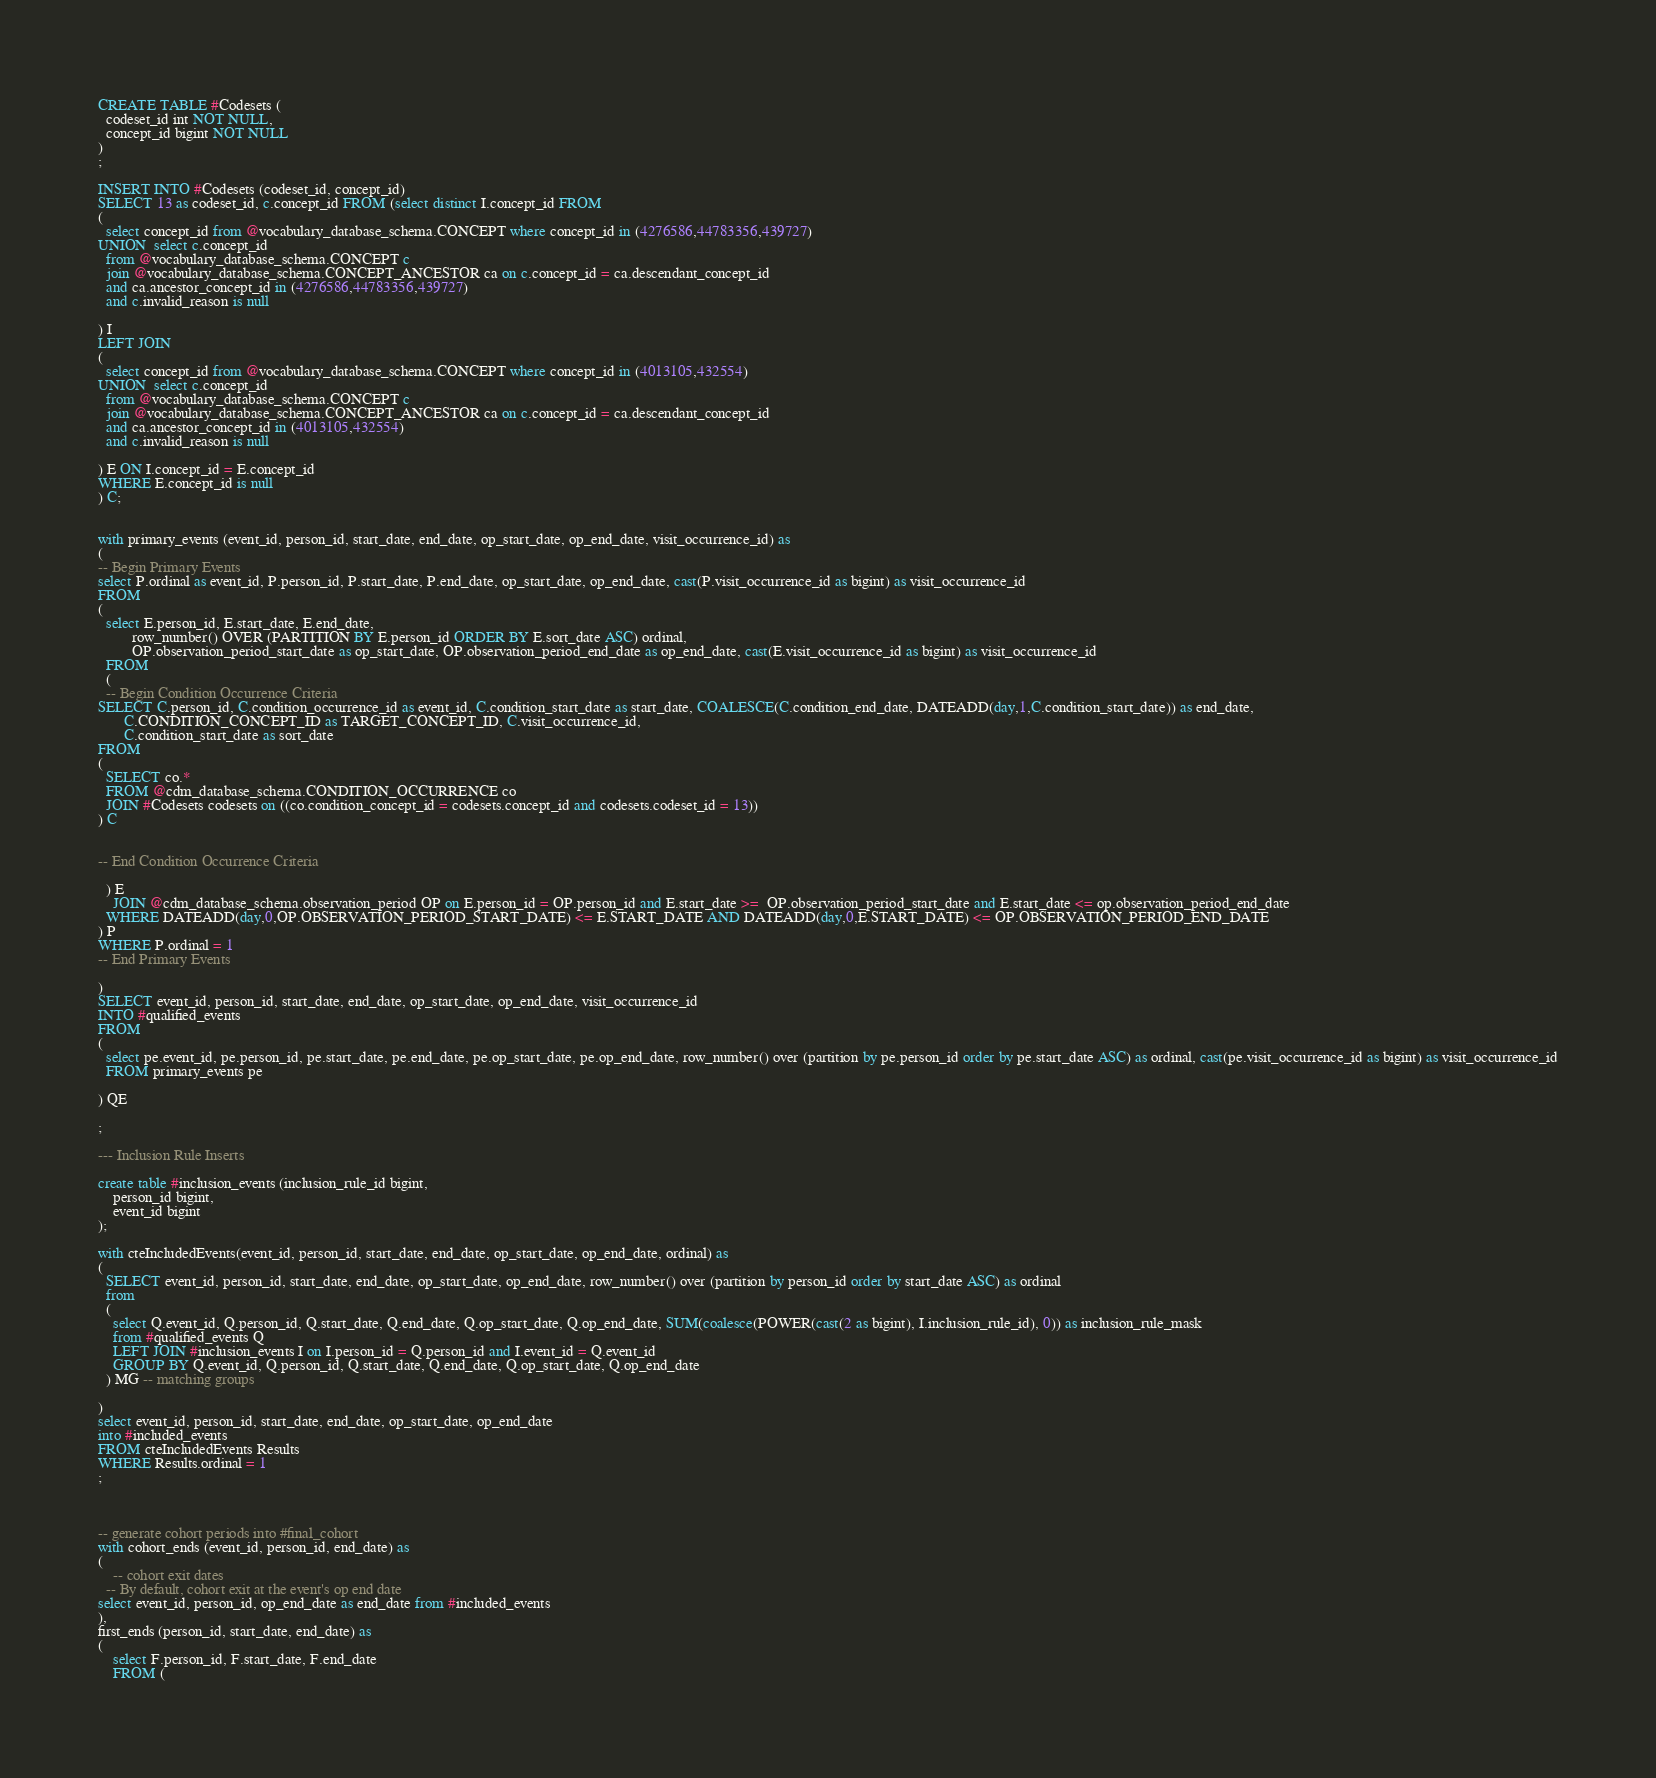Convert code to text. <code><loc_0><loc_0><loc_500><loc_500><_SQL_>CREATE TABLE #Codesets (
  codeset_id int NOT NULL,
  concept_id bigint NOT NULL
)
;

INSERT INTO #Codesets (codeset_id, concept_id)
SELECT 13 as codeset_id, c.concept_id FROM (select distinct I.concept_id FROM
( 
  select concept_id from @vocabulary_database_schema.CONCEPT where concept_id in (4276586,44783356,439727)
UNION  select c.concept_id
  from @vocabulary_database_schema.CONCEPT c
  join @vocabulary_database_schema.CONCEPT_ANCESTOR ca on c.concept_id = ca.descendant_concept_id
  and ca.ancestor_concept_id in (4276586,44783356,439727)
  and c.invalid_reason is null

) I
LEFT JOIN
(
  select concept_id from @vocabulary_database_schema.CONCEPT where concept_id in (4013105,432554)
UNION  select c.concept_id
  from @vocabulary_database_schema.CONCEPT c
  join @vocabulary_database_schema.CONCEPT_ANCESTOR ca on c.concept_id = ca.descendant_concept_id
  and ca.ancestor_concept_id in (4013105,432554)
  and c.invalid_reason is null

) E ON I.concept_id = E.concept_id
WHERE E.concept_id is null
) C;


with primary_events (event_id, person_id, start_date, end_date, op_start_date, op_end_date, visit_occurrence_id) as
(
-- Begin Primary Events
select P.ordinal as event_id, P.person_id, P.start_date, P.end_date, op_start_date, op_end_date, cast(P.visit_occurrence_id as bigint) as visit_occurrence_id
FROM
(
  select E.person_id, E.start_date, E.end_date,
         row_number() OVER (PARTITION BY E.person_id ORDER BY E.sort_date ASC) ordinal,
         OP.observation_period_start_date as op_start_date, OP.observation_period_end_date as op_end_date, cast(E.visit_occurrence_id as bigint) as visit_occurrence_id
  FROM 
  (
  -- Begin Condition Occurrence Criteria
SELECT C.person_id, C.condition_occurrence_id as event_id, C.condition_start_date as start_date, COALESCE(C.condition_end_date, DATEADD(day,1,C.condition_start_date)) as end_date,
       C.CONDITION_CONCEPT_ID as TARGET_CONCEPT_ID, C.visit_occurrence_id,
       C.condition_start_date as sort_date
FROM 
(
  SELECT co.* 
  FROM @cdm_database_schema.CONDITION_OCCURRENCE co
  JOIN #Codesets codesets on ((co.condition_concept_id = codesets.concept_id and codesets.codeset_id = 13))
) C


-- End Condition Occurrence Criteria

  ) E
	JOIN @cdm_database_schema.observation_period OP on E.person_id = OP.person_id and E.start_date >=  OP.observation_period_start_date and E.start_date <= op.observation_period_end_date
  WHERE DATEADD(day,0,OP.OBSERVATION_PERIOD_START_DATE) <= E.START_DATE AND DATEADD(day,0,E.START_DATE) <= OP.OBSERVATION_PERIOD_END_DATE
) P
WHERE P.ordinal = 1
-- End Primary Events

)
SELECT event_id, person_id, start_date, end_date, op_start_date, op_end_date, visit_occurrence_id
INTO #qualified_events
FROM 
(
  select pe.event_id, pe.person_id, pe.start_date, pe.end_date, pe.op_start_date, pe.op_end_date, row_number() over (partition by pe.person_id order by pe.start_date ASC) as ordinal, cast(pe.visit_occurrence_id as bigint) as visit_occurrence_id
  FROM primary_events pe
  
) QE

;

--- Inclusion Rule Inserts

create table #inclusion_events (inclusion_rule_id bigint,
	person_id bigint,
	event_id bigint
);

with cteIncludedEvents(event_id, person_id, start_date, end_date, op_start_date, op_end_date, ordinal) as
(
  SELECT event_id, person_id, start_date, end_date, op_start_date, op_end_date, row_number() over (partition by person_id order by start_date ASC) as ordinal
  from
  (
    select Q.event_id, Q.person_id, Q.start_date, Q.end_date, Q.op_start_date, Q.op_end_date, SUM(coalesce(POWER(cast(2 as bigint), I.inclusion_rule_id), 0)) as inclusion_rule_mask
    from #qualified_events Q
    LEFT JOIN #inclusion_events I on I.person_id = Q.person_id and I.event_id = Q.event_id
    GROUP BY Q.event_id, Q.person_id, Q.start_date, Q.end_date, Q.op_start_date, Q.op_end_date
  ) MG -- matching groups

)
select event_id, person_id, start_date, end_date, op_start_date, op_end_date
into #included_events
FROM cteIncludedEvents Results
WHERE Results.ordinal = 1
;



-- generate cohort periods into #final_cohort
with cohort_ends (event_id, person_id, end_date) as
(
	-- cohort exit dates
  -- By default, cohort exit at the event's op end date
select event_id, person_id, op_end_date as end_date from #included_events
),
first_ends (person_id, start_date, end_date) as
(
	select F.person_id, F.start_date, F.end_date
	FROM (</code> 